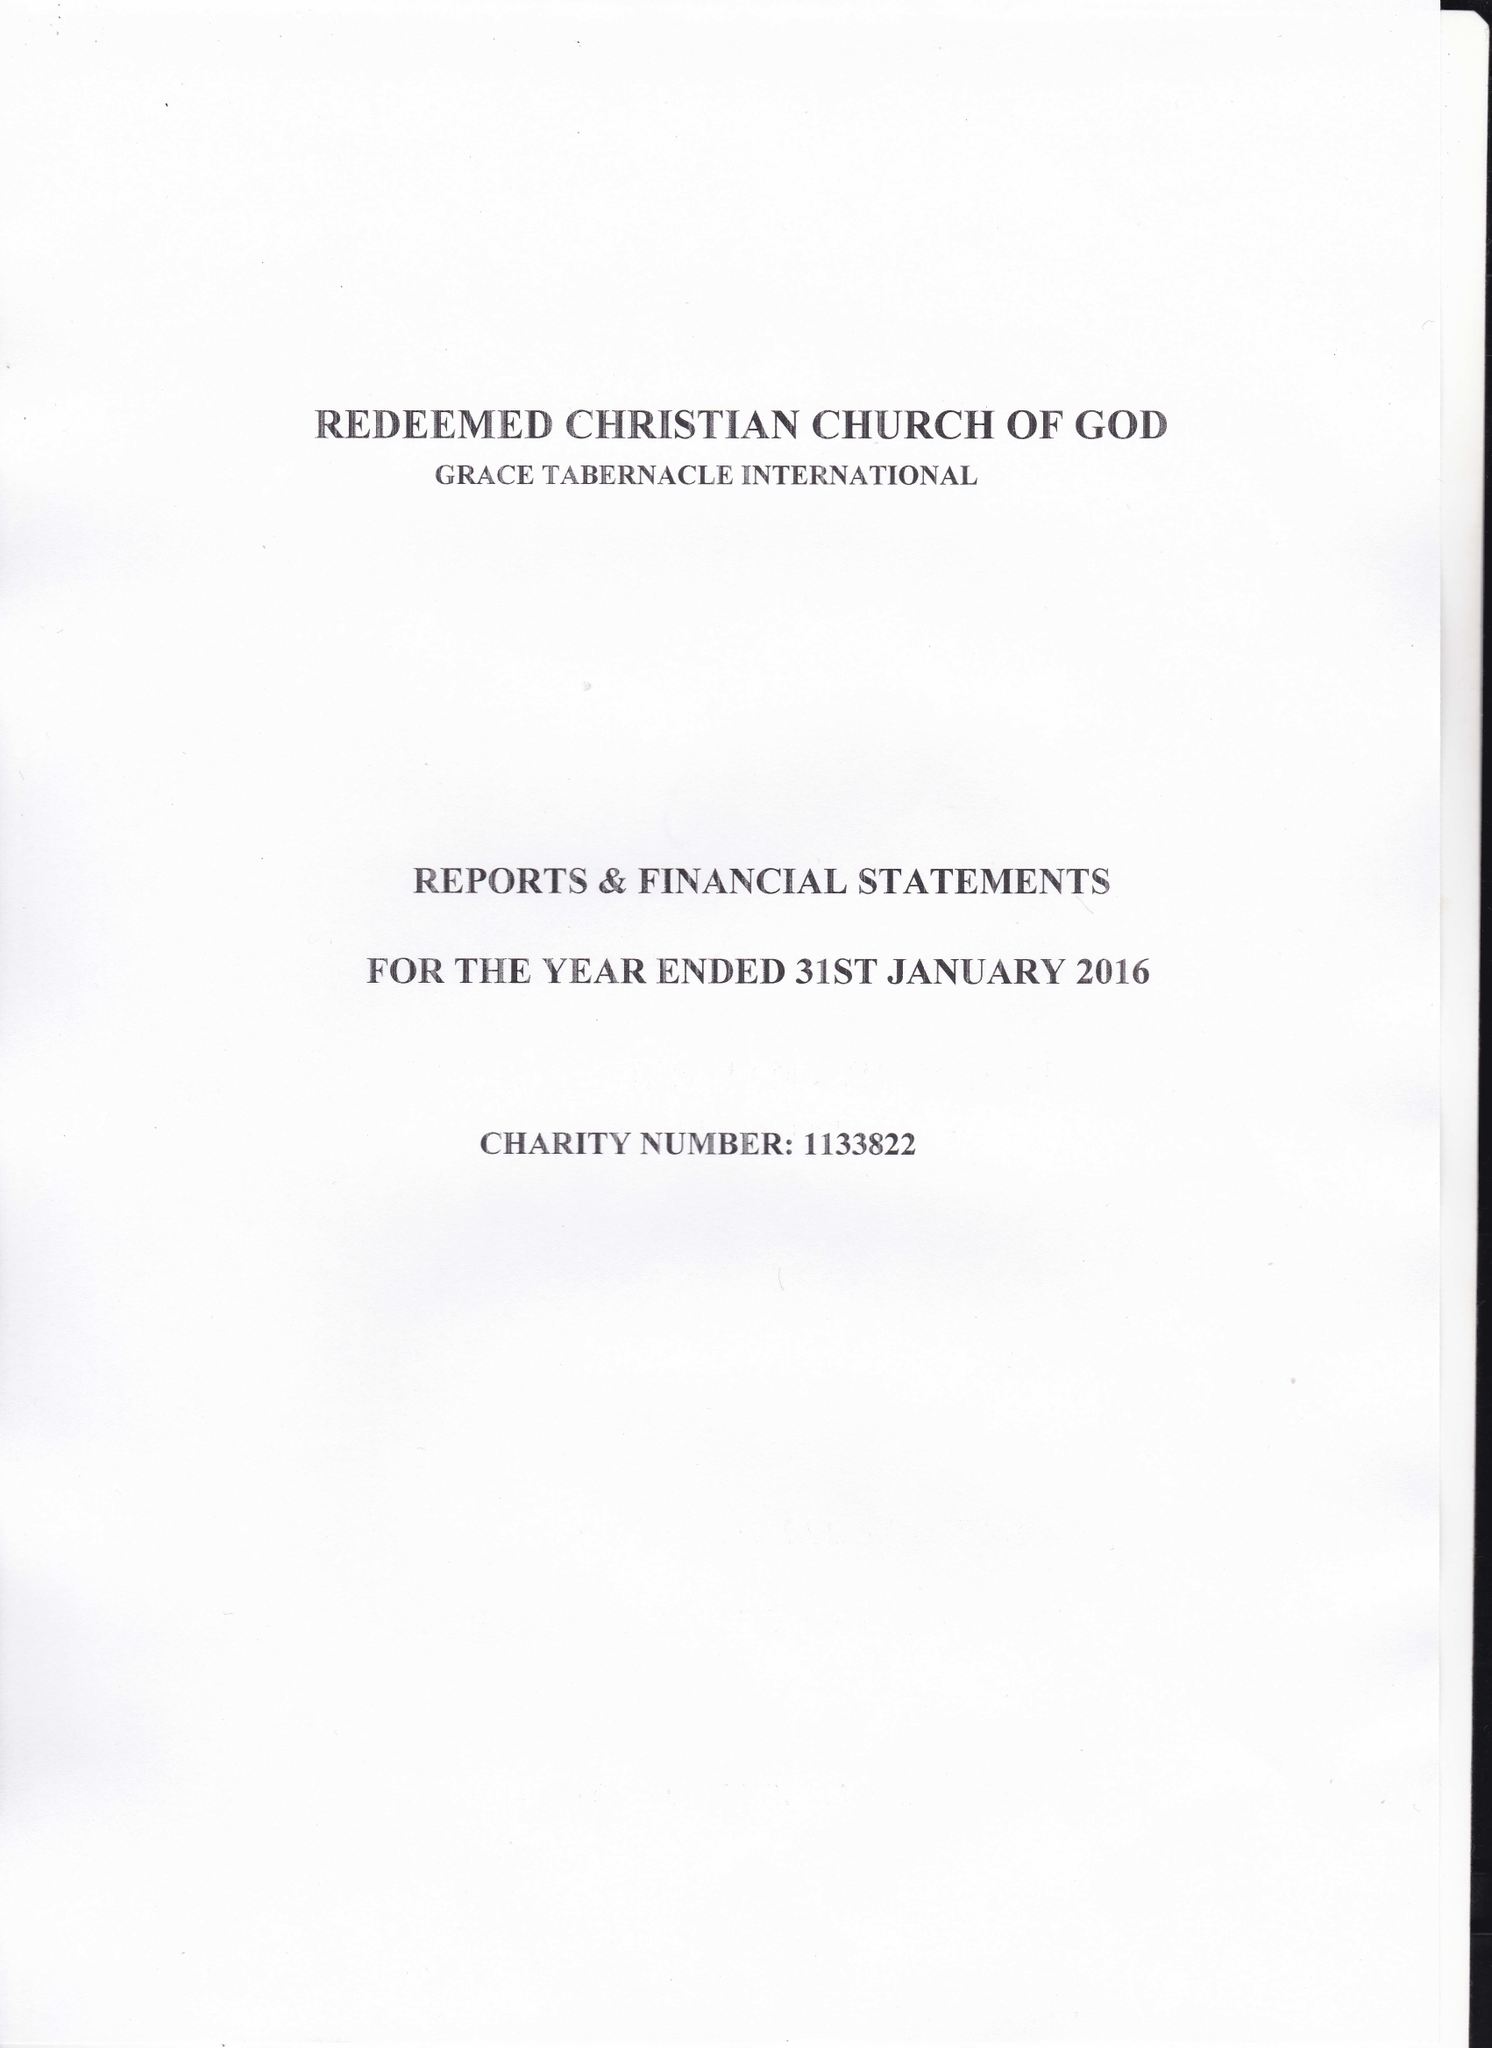What is the value for the charity_number?
Answer the question using a single word or phrase. 1133822 